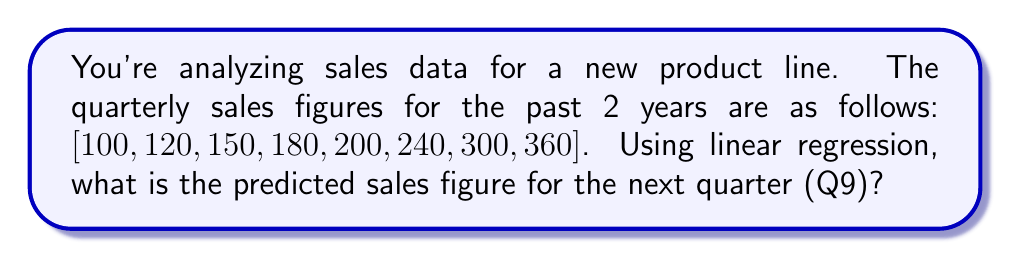Help me with this question. Let's approach this step-by-step using linear regression:

1) First, we need to set up our data. Let $x$ represent the quarter number and $y$ represent the sales:

   $x = [1, 2, 3, 4, 5, 6, 7, 8]$
   $y = [100, 120, 150, 180, 200, 240, 300, 360]$

2) For linear regression, we use the formula:
   $y = mx + b$
   where $m$ is the slope and $b$ is the y-intercept.

3) To find $m$ and $b$, we use these formulas:

   $m = \frac{n\sum xy - \sum x \sum y}{n\sum x^2 - (\sum x)^2}$

   $b = \frac{\sum y - m\sum x}{n}$

   where $n$ is the number of data points (8 in this case).

4) Let's calculate the sums we need:
   $\sum x = 36$
   $\sum y = 1650$
   $\sum xy = 9780$
   $\sum x^2 = 204$

5) Now we can calculate $m$:
   
   $m = \frac{8(9780) - 36(1650)}{8(204) - 36^2} = \frac{78240 - 59400}{1632 - 1296} = \frac{18840}{336} = 56.07$

6) And $b$:

   $b = \frac{1650 - 56.07(36)}{8} = \frac{1650 - 2018.52}{8} = -46.07$

7) So our regression line is:
   $y = 56.07x - 46.07$

8) To predict the sales for Q9, we substitute $x = 9$:

   $y = 56.07(9) - 46.07 = 504.56 - 46.07 = 458.49$

Therefore, the predicted sales figure for Q9 is approximately 458.49.
Answer: 458.49 